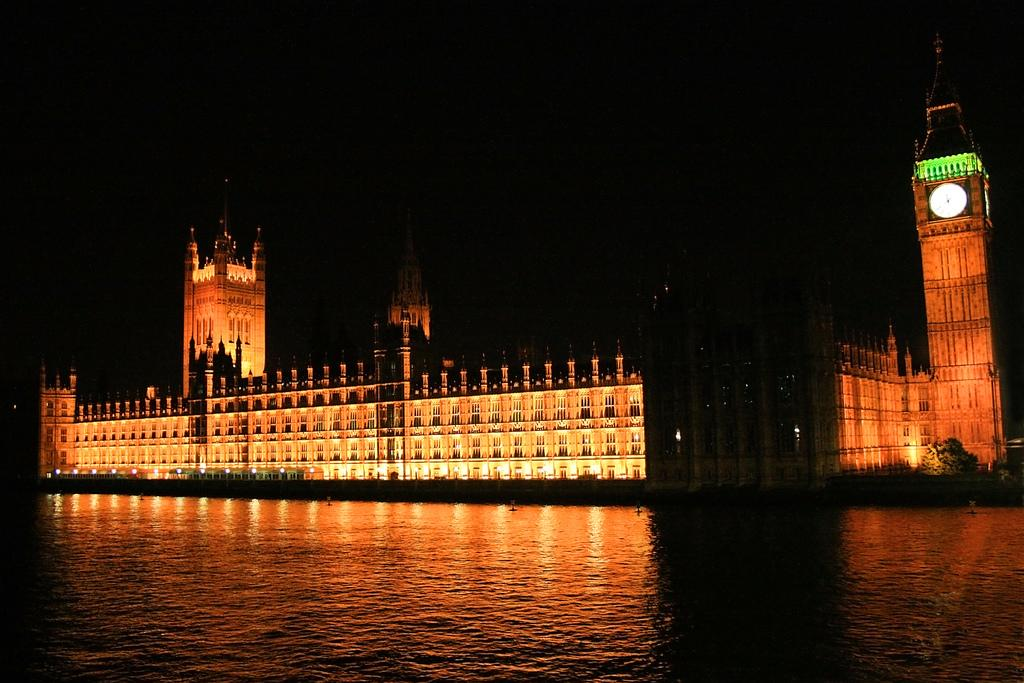What structure is featured in the image with a clock? There is a building with a clock in the image. What can be seen at the bottom of the image? Water is visible at the bottom of the image. Where is the plant located in the image? There is a plant on the right side of the image. How many people are being held in the jail in the image? There is no jail present in the image. What type of animal is biting the plant in the image? There are no animals present in the image, and the plant is not being bitten. 